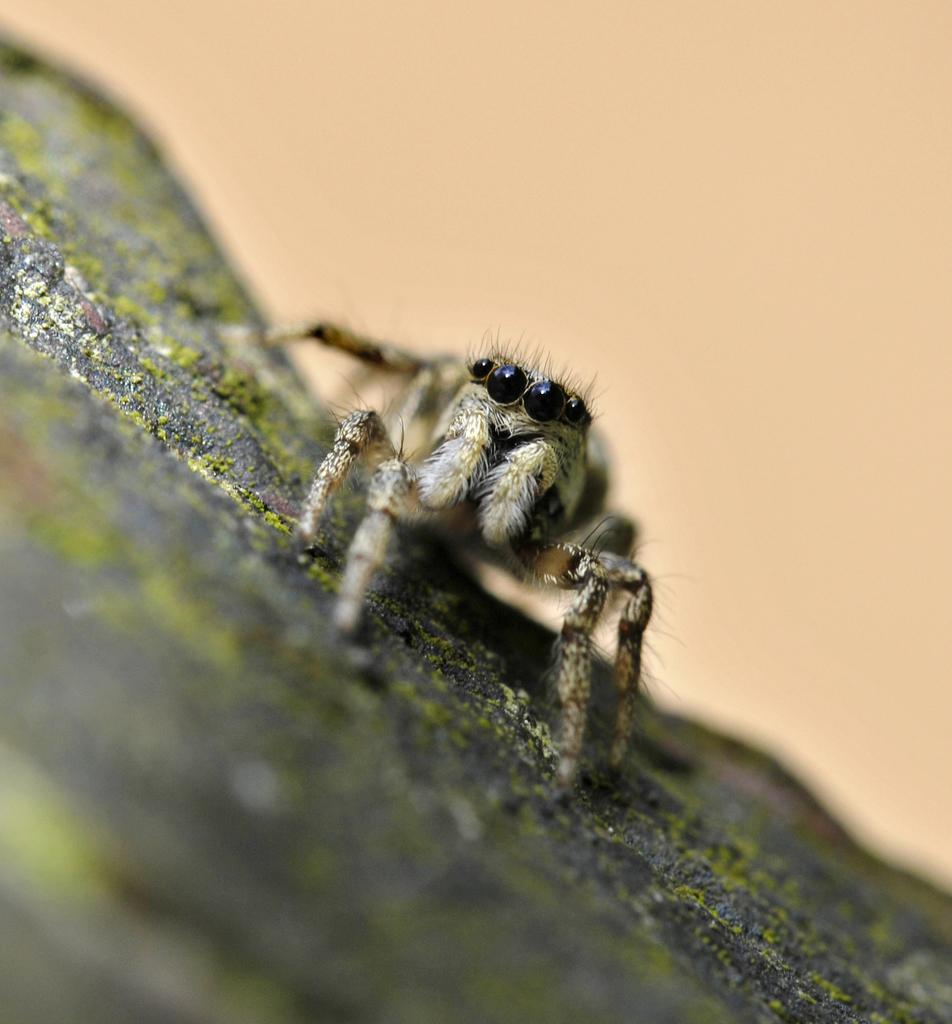What is the main subject of the image? There is a spider in the image. Can you describe the background of the image? The background of the image is blurred. What type of bit is the spider using to carry the basket in the image? There is no basket or bit present in the image; it only features a spider. What kind of lamp is illuminating the spider in the image? There is no lamp present in the image; the spider is not illuminated by any artificial light source. 